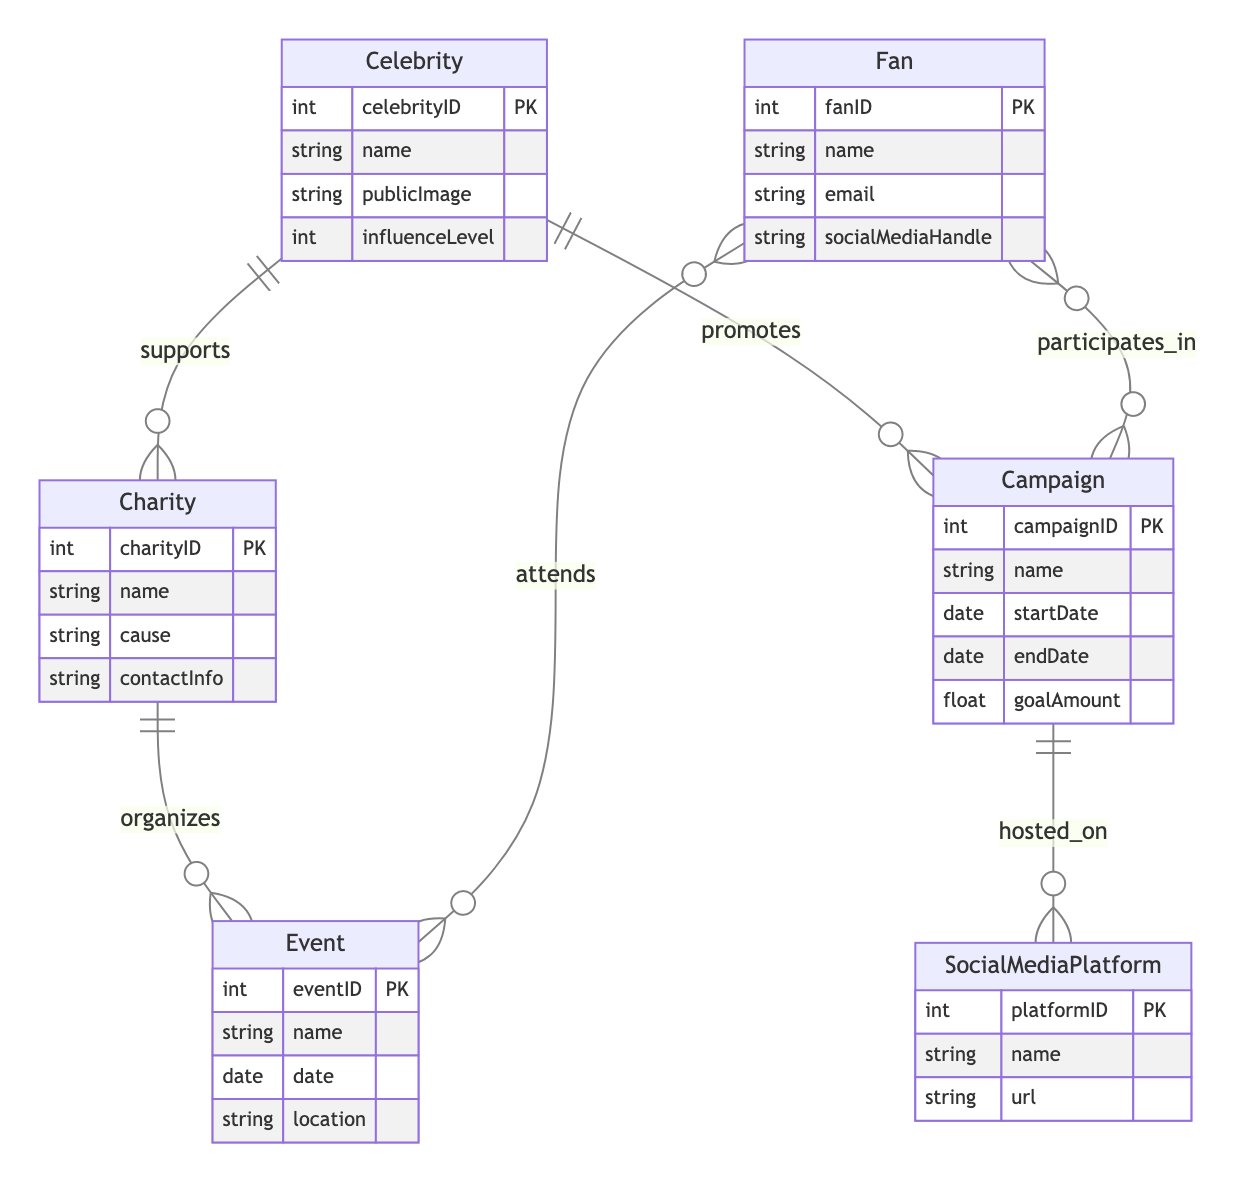What entities are represented in the diagram? The diagram includes six entities: Celebrity, Charity, Event, SocialMediaPlatform, Campaign, and Fan. Each represents a key component in the fan engagement and social media campaigns for charity events.
Answer: Celebrity, Charity, Event, SocialMediaPlatform, Campaign, Fan How many attributes does the Charity entity have? The Charity entity has four attributes: charityID, name, cause, and contactInfo. Each attribute captures essential information about the charity organization.
Answer: 4 What type of relationship exists between Celebrity and Campaign? The relationship between Celebrity and Campaign is represented as "promotes," indicating that a celebrity actively promotes a particular campaign for the charity event.
Answer: promotes How many entities are participating in campaigns? The participating entities in campaigns are Fan and Celebrity, as both are connected through the "participates_in" and "promotes" relationships, respectively. Therefore, there are two entities.
Answer: 2 Which entity organizes events? The entity that organizes events is Charity. The relationship "organizes" indicates that charities manage and oversee the events associated with their causes.
Answer: Charity What additional attribute is included in the "participates_in" relationship? The attribute included in the "participates_in" relationship is "donationAmount," which signifies a fan's contribution to a campaign.
Answer: donationAmount How many social media platforms can campaigns be hosted on? Campaigns can be hosted on multiple social media platforms, as indicated by the relationship "hosted_on." Since there is no specified limit in the diagram, it can be several.
Answer: Multiple What does the influence level attribute signify? The influence level attribute indicates the impact a celebrity has on supporting a particular charity or campaign. It reflects their ability to engage fans and donors effectively.
Answer: Impact What type of information does the Event entity provide? The Event entity provides information related to specific charity events, including its name, date, and location. This information is crucial for attendees and participants.
Answer: Name, date, location 